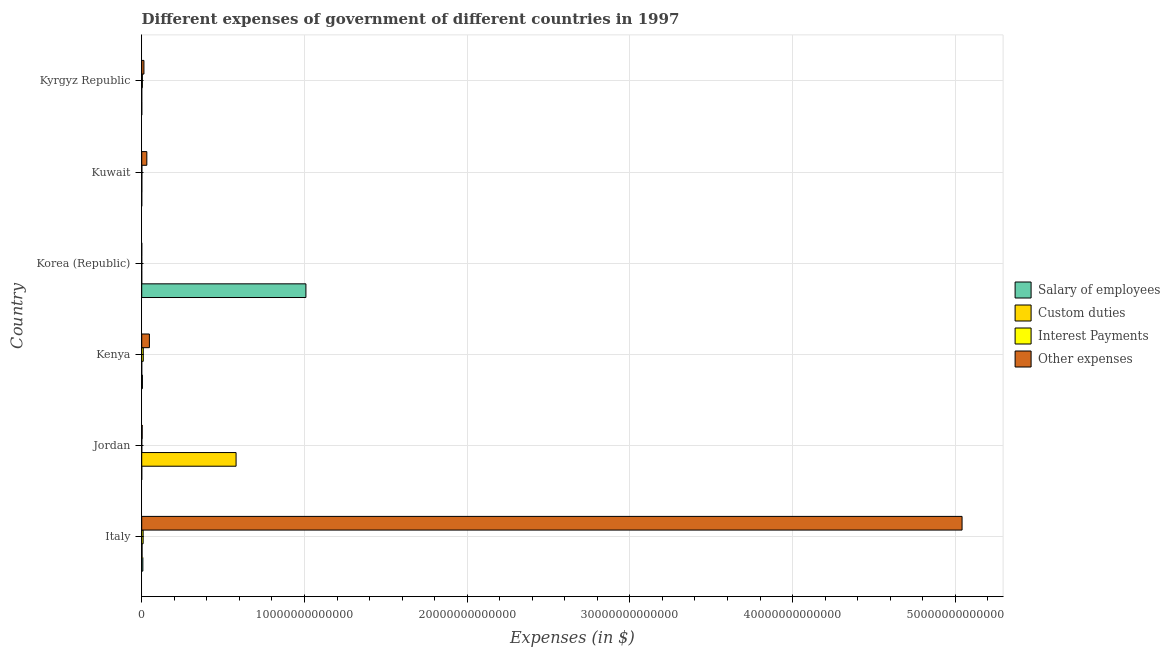Are the number of bars per tick equal to the number of legend labels?
Offer a terse response. Yes. Are the number of bars on each tick of the Y-axis equal?
Offer a very short reply. Yes. How many bars are there on the 2nd tick from the top?
Your answer should be very brief. 4. What is the label of the 1st group of bars from the top?
Provide a succinct answer. Kyrgyz Republic. In how many cases, is the number of bars for a given country not equal to the number of legend labels?
Offer a terse response. 0. What is the amount spent on custom duties in Kuwait?
Keep it short and to the point. 6.52e+09. Across all countries, what is the maximum amount spent on interest payments?
Offer a very short reply. 9.54e+1. Across all countries, what is the minimum amount spent on interest payments?
Keep it short and to the point. 2.01e+08. What is the total amount spent on custom duties in the graph?
Offer a very short reply. 5.83e+12. What is the difference between the amount spent on salary of employees in Jordan and that in Kenya?
Provide a succinct answer. -4.16e+1. What is the difference between the amount spent on custom duties in Kyrgyz Republic and the amount spent on interest payments in Italy?
Ensure brevity in your answer.  -8.64e+1. What is the average amount spent on custom duties per country?
Give a very brief answer. 9.71e+11. What is the difference between the amount spent on other expenses and amount spent on interest payments in Korea (Republic)?
Offer a very short reply. 1.26e+09. What is the ratio of the amount spent on other expenses in Italy to that in Kuwait?
Offer a very short reply. 160.86. Is the difference between the amount spent on interest payments in Kenya and Korea (Republic) greater than the difference between the amount spent on custom duties in Kenya and Korea (Republic)?
Your answer should be very brief. Yes. What is the difference between the highest and the second highest amount spent on interest payments?
Your answer should be compact. 8.35e+09. What is the difference between the highest and the lowest amount spent on other expenses?
Provide a succinct answer. 5.04e+13. What does the 2nd bar from the top in Kenya represents?
Ensure brevity in your answer.  Interest Payments. What does the 2nd bar from the bottom in Kuwait represents?
Your answer should be compact. Custom duties. How many bars are there?
Your answer should be compact. 24. What is the difference between two consecutive major ticks on the X-axis?
Provide a short and direct response. 1.00e+13. Are the values on the major ticks of X-axis written in scientific E-notation?
Ensure brevity in your answer.  No. Does the graph contain grids?
Your answer should be compact. Yes. How many legend labels are there?
Give a very brief answer. 4. How are the legend labels stacked?
Offer a very short reply. Vertical. What is the title of the graph?
Keep it short and to the point. Different expenses of government of different countries in 1997. What is the label or title of the X-axis?
Make the answer very short. Expenses (in $). What is the label or title of the Y-axis?
Provide a succinct answer. Country. What is the Expenses (in $) in Salary of employees in Italy?
Your response must be concise. 7.01e+1. What is the Expenses (in $) in Custom duties in Italy?
Provide a succinct answer. 2.12e+1. What is the Expenses (in $) of Interest Payments in Italy?
Give a very brief answer. 8.70e+1. What is the Expenses (in $) in Other expenses in Italy?
Keep it short and to the point. 5.04e+13. What is the Expenses (in $) of Salary of employees in Jordan?
Your answer should be very brief. 9.72e+08. What is the Expenses (in $) of Custom duties in Jordan?
Your answer should be very brief. 5.80e+12. What is the Expenses (in $) in Interest Payments in Jordan?
Your response must be concise. 3.22e+09. What is the Expenses (in $) of Other expenses in Jordan?
Your response must be concise. 2.88e+1. What is the Expenses (in $) of Salary of employees in Kenya?
Ensure brevity in your answer.  4.26e+1. What is the Expenses (in $) in Custom duties in Kenya?
Keep it short and to the point. 8.30e+07. What is the Expenses (in $) of Interest Payments in Kenya?
Provide a short and direct response. 9.54e+1. What is the Expenses (in $) of Other expenses in Kenya?
Provide a short and direct response. 4.72e+11. What is the Expenses (in $) in Salary of employees in Korea (Republic)?
Give a very brief answer. 1.01e+13. What is the Expenses (in $) in Custom duties in Korea (Republic)?
Provide a short and direct response. 2.20e+07. What is the Expenses (in $) in Interest Payments in Korea (Republic)?
Ensure brevity in your answer.  2.01e+08. What is the Expenses (in $) of Other expenses in Korea (Republic)?
Your answer should be compact. 1.46e+09. What is the Expenses (in $) in Salary of employees in Kuwait?
Give a very brief answer. 1.08e+09. What is the Expenses (in $) in Custom duties in Kuwait?
Your response must be concise. 6.52e+09. What is the Expenses (in $) of Interest Payments in Kuwait?
Make the answer very short. 9.30e+09. What is the Expenses (in $) in Other expenses in Kuwait?
Keep it short and to the point. 3.13e+11. What is the Expenses (in $) in Salary of employees in Kyrgyz Republic?
Provide a short and direct response. 2.20e+09. What is the Expenses (in $) in Custom duties in Kyrgyz Republic?
Your answer should be compact. 5.53e+08. What is the Expenses (in $) of Interest Payments in Kyrgyz Republic?
Provide a succinct answer. 4.00e+1. What is the Expenses (in $) of Other expenses in Kyrgyz Republic?
Your answer should be very brief. 1.36e+11. Across all countries, what is the maximum Expenses (in $) of Salary of employees?
Provide a succinct answer. 1.01e+13. Across all countries, what is the maximum Expenses (in $) of Custom duties?
Give a very brief answer. 5.80e+12. Across all countries, what is the maximum Expenses (in $) in Interest Payments?
Offer a very short reply. 9.54e+1. Across all countries, what is the maximum Expenses (in $) of Other expenses?
Provide a short and direct response. 5.04e+13. Across all countries, what is the minimum Expenses (in $) in Salary of employees?
Provide a succinct answer. 9.72e+08. Across all countries, what is the minimum Expenses (in $) in Custom duties?
Your answer should be compact. 2.20e+07. Across all countries, what is the minimum Expenses (in $) of Interest Payments?
Your answer should be very brief. 2.01e+08. Across all countries, what is the minimum Expenses (in $) of Other expenses?
Provide a short and direct response. 1.46e+09. What is the total Expenses (in $) in Salary of employees in the graph?
Offer a terse response. 1.02e+13. What is the total Expenses (in $) in Custom duties in the graph?
Provide a short and direct response. 5.83e+12. What is the total Expenses (in $) of Interest Payments in the graph?
Your answer should be very brief. 2.35e+11. What is the total Expenses (in $) in Other expenses in the graph?
Provide a succinct answer. 5.14e+13. What is the difference between the Expenses (in $) of Salary of employees in Italy and that in Jordan?
Offer a very short reply. 6.91e+1. What is the difference between the Expenses (in $) in Custom duties in Italy and that in Jordan?
Offer a terse response. -5.78e+12. What is the difference between the Expenses (in $) of Interest Payments in Italy and that in Jordan?
Keep it short and to the point. 8.38e+1. What is the difference between the Expenses (in $) of Other expenses in Italy and that in Jordan?
Keep it short and to the point. 5.04e+13. What is the difference between the Expenses (in $) in Salary of employees in Italy and that in Kenya?
Provide a succinct answer. 2.75e+1. What is the difference between the Expenses (in $) in Custom duties in Italy and that in Kenya?
Offer a terse response. 2.11e+1. What is the difference between the Expenses (in $) of Interest Payments in Italy and that in Kenya?
Your response must be concise. -8.35e+09. What is the difference between the Expenses (in $) in Other expenses in Italy and that in Kenya?
Make the answer very short. 4.99e+13. What is the difference between the Expenses (in $) of Salary of employees in Italy and that in Korea (Republic)?
Your answer should be compact. -1.00e+13. What is the difference between the Expenses (in $) of Custom duties in Italy and that in Korea (Republic)?
Provide a short and direct response. 2.12e+1. What is the difference between the Expenses (in $) of Interest Payments in Italy and that in Korea (Republic)?
Offer a very short reply. 8.68e+1. What is the difference between the Expenses (in $) in Other expenses in Italy and that in Korea (Republic)?
Your answer should be compact. 5.04e+13. What is the difference between the Expenses (in $) of Salary of employees in Italy and that in Kuwait?
Give a very brief answer. 6.90e+1. What is the difference between the Expenses (in $) of Custom duties in Italy and that in Kuwait?
Your answer should be very brief. 1.47e+1. What is the difference between the Expenses (in $) in Interest Payments in Italy and that in Kuwait?
Ensure brevity in your answer.  7.77e+1. What is the difference between the Expenses (in $) of Other expenses in Italy and that in Kuwait?
Make the answer very short. 5.01e+13. What is the difference between the Expenses (in $) in Salary of employees in Italy and that in Kyrgyz Republic?
Keep it short and to the point. 6.79e+1. What is the difference between the Expenses (in $) in Custom duties in Italy and that in Kyrgyz Republic?
Make the answer very short. 2.06e+1. What is the difference between the Expenses (in $) of Interest Payments in Italy and that in Kyrgyz Republic?
Keep it short and to the point. 4.70e+1. What is the difference between the Expenses (in $) of Other expenses in Italy and that in Kyrgyz Republic?
Offer a terse response. 5.03e+13. What is the difference between the Expenses (in $) in Salary of employees in Jordan and that in Kenya?
Ensure brevity in your answer.  -4.16e+1. What is the difference between the Expenses (in $) of Custom duties in Jordan and that in Kenya?
Make the answer very short. 5.80e+12. What is the difference between the Expenses (in $) in Interest Payments in Jordan and that in Kenya?
Offer a very short reply. -9.21e+1. What is the difference between the Expenses (in $) of Other expenses in Jordan and that in Kenya?
Offer a very short reply. -4.43e+11. What is the difference between the Expenses (in $) of Salary of employees in Jordan and that in Korea (Republic)?
Offer a very short reply. -1.01e+13. What is the difference between the Expenses (in $) in Custom duties in Jordan and that in Korea (Republic)?
Provide a succinct answer. 5.80e+12. What is the difference between the Expenses (in $) of Interest Payments in Jordan and that in Korea (Republic)?
Offer a very short reply. 3.02e+09. What is the difference between the Expenses (in $) of Other expenses in Jordan and that in Korea (Republic)?
Offer a very short reply. 2.74e+1. What is the difference between the Expenses (in $) in Salary of employees in Jordan and that in Kuwait?
Keep it short and to the point. -1.03e+08. What is the difference between the Expenses (in $) of Custom duties in Jordan and that in Kuwait?
Make the answer very short. 5.79e+12. What is the difference between the Expenses (in $) in Interest Payments in Jordan and that in Kuwait?
Make the answer very short. -6.08e+09. What is the difference between the Expenses (in $) of Other expenses in Jordan and that in Kuwait?
Offer a very short reply. -2.85e+11. What is the difference between the Expenses (in $) in Salary of employees in Jordan and that in Kyrgyz Republic?
Offer a very short reply. -1.22e+09. What is the difference between the Expenses (in $) in Custom duties in Jordan and that in Kyrgyz Republic?
Your answer should be compact. 5.80e+12. What is the difference between the Expenses (in $) in Interest Payments in Jordan and that in Kyrgyz Republic?
Your response must be concise. -3.68e+1. What is the difference between the Expenses (in $) of Other expenses in Jordan and that in Kyrgyz Republic?
Make the answer very short. -1.08e+11. What is the difference between the Expenses (in $) in Salary of employees in Kenya and that in Korea (Republic)?
Provide a short and direct response. -1.00e+13. What is the difference between the Expenses (in $) of Custom duties in Kenya and that in Korea (Republic)?
Offer a terse response. 6.10e+07. What is the difference between the Expenses (in $) of Interest Payments in Kenya and that in Korea (Republic)?
Your answer should be very brief. 9.52e+1. What is the difference between the Expenses (in $) in Other expenses in Kenya and that in Korea (Republic)?
Offer a very short reply. 4.70e+11. What is the difference between the Expenses (in $) in Salary of employees in Kenya and that in Kuwait?
Your response must be concise. 4.15e+1. What is the difference between the Expenses (in $) in Custom duties in Kenya and that in Kuwait?
Your response must be concise. -6.44e+09. What is the difference between the Expenses (in $) in Interest Payments in Kenya and that in Kuwait?
Offer a terse response. 8.61e+1. What is the difference between the Expenses (in $) in Other expenses in Kenya and that in Kuwait?
Provide a short and direct response. 1.58e+11. What is the difference between the Expenses (in $) of Salary of employees in Kenya and that in Kyrgyz Republic?
Your answer should be very brief. 4.04e+1. What is the difference between the Expenses (in $) of Custom duties in Kenya and that in Kyrgyz Republic?
Give a very brief answer. -4.70e+08. What is the difference between the Expenses (in $) of Interest Payments in Kenya and that in Kyrgyz Republic?
Provide a short and direct response. 5.54e+1. What is the difference between the Expenses (in $) in Other expenses in Kenya and that in Kyrgyz Republic?
Your response must be concise. 3.35e+11. What is the difference between the Expenses (in $) in Salary of employees in Korea (Republic) and that in Kuwait?
Your answer should be compact. 1.01e+13. What is the difference between the Expenses (in $) of Custom duties in Korea (Republic) and that in Kuwait?
Give a very brief answer. -6.50e+09. What is the difference between the Expenses (in $) of Interest Payments in Korea (Republic) and that in Kuwait?
Provide a succinct answer. -9.10e+09. What is the difference between the Expenses (in $) of Other expenses in Korea (Republic) and that in Kuwait?
Keep it short and to the point. -3.12e+11. What is the difference between the Expenses (in $) in Salary of employees in Korea (Republic) and that in Kyrgyz Republic?
Offer a terse response. 1.01e+13. What is the difference between the Expenses (in $) in Custom duties in Korea (Republic) and that in Kyrgyz Republic?
Offer a terse response. -5.31e+08. What is the difference between the Expenses (in $) in Interest Payments in Korea (Republic) and that in Kyrgyz Republic?
Your response must be concise. -3.98e+1. What is the difference between the Expenses (in $) of Other expenses in Korea (Republic) and that in Kyrgyz Republic?
Provide a succinct answer. -1.35e+11. What is the difference between the Expenses (in $) in Salary of employees in Kuwait and that in Kyrgyz Republic?
Provide a short and direct response. -1.12e+09. What is the difference between the Expenses (in $) in Custom duties in Kuwait and that in Kyrgyz Republic?
Your response must be concise. 5.97e+09. What is the difference between the Expenses (in $) in Interest Payments in Kuwait and that in Kyrgyz Republic?
Your answer should be compact. -3.07e+1. What is the difference between the Expenses (in $) of Other expenses in Kuwait and that in Kyrgyz Republic?
Give a very brief answer. 1.77e+11. What is the difference between the Expenses (in $) of Salary of employees in Italy and the Expenses (in $) of Custom duties in Jordan?
Offer a terse response. -5.73e+12. What is the difference between the Expenses (in $) of Salary of employees in Italy and the Expenses (in $) of Interest Payments in Jordan?
Offer a very short reply. 6.69e+1. What is the difference between the Expenses (in $) of Salary of employees in Italy and the Expenses (in $) of Other expenses in Jordan?
Give a very brief answer. 4.13e+1. What is the difference between the Expenses (in $) of Custom duties in Italy and the Expenses (in $) of Interest Payments in Jordan?
Ensure brevity in your answer.  1.80e+1. What is the difference between the Expenses (in $) of Custom duties in Italy and the Expenses (in $) of Other expenses in Jordan?
Provide a short and direct response. -7.65e+09. What is the difference between the Expenses (in $) of Interest Payments in Italy and the Expenses (in $) of Other expenses in Jordan?
Your response must be concise. 5.82e+1. What is the difference between the Expenses (in $) of Salary of employees in Italy and the Expenses (in $) of Custom duties in Kenya?
Offer a terse response. 7.00e+1. What is the difference between the Expenses (in $) of Salary of employees in Italy and the Expenses (in $) of Interest Payments in Kenya?
Keep it short and to the point. -2.52e+1. What is the difference between the Expenses (in $) of Salary of employees in Italy and the Expenses (in $) of Other expenses in Kenya?
Your answer should be compact. -4.01e+11. What is the difference between the Expenses (in $) in Custom duties in Italy and the Expenses (in $) in Interest Payments in Kenya?
Make the answer very short. -7.42e+1. What is the difference between the Expenses (in $) of Custom duties in Italy and the Expenses (in $) of Other expenses in Kenya?
Offer a terse response. -4.50e+11. What is the difference between the Expenses (in $) in Interest Payments in Italy and the Expenses (in $) in Other expenses in Kenya?
Your answer should be compact. -3.85e+11. What is the difference between the Expenses (in $) in Salary of employees in Italy and the Expenses (in $) in Custom duties in Korea (Republic)?
Your answer should be compact. 7.01e+1. What is the difference between the Expenses (in $) in Salary of employees in Italy and the Expenses (in $) in Interest Payments in Korea (Republic)?
Provide a short and direct response. 6.99e+1. What is the difference between the Expenses (in $) of Salary of employees in Italy and the Expenses (in $) of Other expenses in Korea (Republic)?
Provide a short and direct response. 6.86e+1. What is the difference between the Expenses (in $) of Custom duties in Italy and the Expenses (in $) of Interest Payments in Korea (Republic)?
Offer a terse response. 2.10e+1. What is the difference between the Expenses (in $) in Custom duties in Italy and the Expenses (in $) in Other expenses in Korea (Republic)?
Ensure brevity in your answer.  1.97e+1. What is the difference between the Expenses (in $) of Interest Payments in Italy and the Expenses (in $) of Other expenses in Korea (Republic)?
Your answer should be very brief. 8.55e+1. What is the difference between the Expenses (in $) of Salary of employees in Italy and the Expenses (in $) of Custom duties in Kuwait?
Your answer should be compact. 6.36e+1. What is the difference between the Expenses (in $) of Salary of employees in Italy and the Expenses (in $) of Interest Payments in Kuwait?
Offer a very short reply. 6.08e+1. What is the difference between the Expenses (in $) of Salary of employees in Italy and the Expenses (in $) of Other expenses in Kuwait?
Make the answer very short. -2.43e+11. What is the difference between the Expenses (in $) in Custom duties in Italy and the Expenses (in $) in Interest Payments in Kuwait?
Offer a terse response. 1.19e+1. What is the difference between the Expenses (in $) in Custom duties in Italy and the Expenses (in $) in Other expenses in Kuwait?
Ensure brevity in your answer.  -2.92e+11. What is the difference between the Expenses (in $) in Interest Payments in Italy and the Expenses (in $) in Other expenses in Kuwait?
Provide a succinct answer. -2.26e+11. What is the difference between the Expenses (in $) in Salary of employees in Italy and the Expenses (in $) in Custom duties in Kyrgyz Republic?
Offer a very short reply. 6.96e+1. What is the difference between the Expenses (in $) of Salary of employees in Italy and the Expenses (in $) of Interest Payments in Kyrgyz Republic?
Ensure brevity in your answer.  3.01e+1. What is the difference between the Expenses (in $) in Salary of employees in Italy and the Expenses (in $) in Other expenses in Kyrgyz Republic?
Provide a short and direct response. -6.64e+1. What is the difference between the Expenses (in $) in Custom duties in Italy and the Expenses (in $) in Interest Payments in Kyrgyz Republic?
Provide a succinct answer. -1.88e+1. What is the difference between the Expenses (in $) in Custom duties in Italy and the Expenses (in $) in Other expenses in Kyrgyz Republic?
Keep it short and to the point. -1.15e+11. What is the difference between the Expenses (in $) in Interest Payments in Italy and the Expenses (in $) in Other expenses in Kyrgyz Republic?
Provide a short and direct response. -4.95e+1. What is the difference between the Expenses (in $) in Salary of employees in Jordan and the Expenses (in $) in Custom duties in Kenya?
Provide a short and direct response. 8.89e+08. What is the difference between the Expenses (in $) of Salary of employees in Jordan and the Expenses (in $) of Interest Payments in Kenya?
Offer a terse response. -9.44e+1. What is the difference between the Expenses (in $) of Salary of employees in Jordan and the Expenses (in $) of Other expenses in Kenya?
Offer a terse response. -4.71e+11. What is the difference between the Expenses (in $) in Custom duties in Jordan and the Expenses (in $) in Interest Payments in Kenya?
Provide a short and direct response. 5.70e+12. What is the difference between the Expenses (in $) of Custom duties in Jordan and the Expenses (in $) of Other expenses in Kenya?
Provide a succinct answer. 5.33e+12. What is the difference between the Expenses (in $) of Interest Payments in Jordan and the Expenses (in $) of Other expenses in Kenya?
Provide a succinct answer. -4.68e+11. What is the difference between the Expenses (in $) in Salary of employees in Jordan and the Expenses (in $) in Custom duties in Korea (Republic)?
Provide a succinct answer. 9.50e+08. What is the difference between the Expenses (in $) in Salary of employees in Jordan and the Expenses (in $) in Interest Payments in Korea (Republic)?
Provide a succinct answer. 7.72e+08. What is the difference between the Expenses (in $) in Salary of employees in Jordan and the Expenses (in $) in Other expenses in Korea (Republic)?
Keep it short and to the point. -4.88e+08. What is the difference between the Expenses (in $) of Custom duties in Jordan and the Expenses (in $) of Interest Payments in Korea (Republic)?
Your answer should be compact. 5.80e+12. What is the difference between the Expenses (in $) of Custom duties in Jordan and the Expenses (in $) of Other expenses in Korea (Republic)?
Ensure brevity in your answer.  5.80e+12. What is the difference between the Expenses (in $) of Interest Payments in Jordan and the Expenses (in $) of Other expenses in Korea (Republic)?
Offer a very short reply. 1.76e+09. What is the difference between the Expenses (in $) of Salary of employees in Jordan and the Expenses (in $) of Custom duties in Kuwait?
Keep it short and to the point. -5.55e+09. What is the difference between the Expenses (in $) in Salary of employees in Jordan and the Expenses (in $) in Interest Payments in Kuwait?
Keep it short and to the point. -8.33e+09. What is the difference between the Expenses (in $) of Salary of employees in Jordan and the Expenses (in $) of Other expenses in Kuwait?
Your response must be concise. -3.12e+11. What is the difference between the Expenses (in $) in Custom duties in Jordan and the Expenses (in $) in Interest Payments in Kuwait?
Your answer should be very brief. 5.79e+12. What is the difference between the Expenses (in $) of Custom duties in Jordan and the Expenses (in $) of Other expenses in Kuwait?
Provide a succinct answer. 5.48e+12. What is the difference between the Expenses (in $) of Interest Payments in Jordan and the Expenses (in $) of Other expenses in Kuwait?
Provide a short and direct response. -3.10e+11. What is the difference between the Expenses (in $) in Salary of employees in Jordan and the Expenses (in $) in Custom duties in Kyrgyz Republic?
Provide a succinct answer. 4.20e+08. What is the difference between the Expenses (in $) in Salary of employees in Jordan and the Expenses (in $) in Interest Payments in Kyrgyz Republic?
Give a very brief answer. -3.90e+1. What is the difference between the Expenses (in $) in Salary of employees in Jordan and the Expenses (in $) in Other expenses in Kyrgyz Republic?
Your answer should be compact. -1.35e+11. What is the difference between the Expenses (in $) of Custom duties in Jordan and the Expenses (in $) of Interest Payments in Kyrgyz Republic?
Ensure brevity in your answer.  5.76e+12. What is the difference between the Expenses (in $) of Custom duties in Jordan and the Expenses (in $) of Other expenses in Kyrgyz Republic?
Your response must be concise. 5.66e+12. What is the difference between the Expenses (in $) of Interest Payments in Jordan and the Expenses (in $) of Other expenses in Kyrgyz Republic?
Keep it short and to the point. -1.33e+11. What is the difference between the Expenses (in $) of Salary of employees in Kenya and the Expenses (in $) of Custom duties in Korea (Republic)?
Provide a short and direct response. 4.25e+1. What is the difference between the Expenses (in $) in Salary of employees in Kenya and the Expenses (in $) in Interest Payments in Korea (Republic)?
Make the answer very short. 4.24e+1. What is the difference between the Expenses (in $) in Salary of employees in Kenya and the Expenses (in $) in Other expenses in Korea (Republic)?
Your response must be concise. 4.11e+1. What is the difference between the Expenses (in $) in Custom duties in Kenya and the Expenses (in $) in Interest Payments in Korea (Republic)?
Ensure brevity in your answer.  -1.18e+08. What is the difference between the Expenses (in $) in Custom duties in Kenya and the Expenses (in $) in Other expenses in Korea (Republic)?
Ensure brevity in your answer.  -1.38e+09. What is the difference between the Expenses (in $) of Interest Payments in Kenya and the Expenses (in $) of Other expenses in Korea (Republic)?
Keep it short and to the point. 9.39e+1. What is the difference between the Expenses (in $) of Salary of employees in Kenya and the Expenses (in $) of Custom duties in Kuwait?
Offer a terse response. 3.60e+1. What is the difference between the Expenses (in $) of Salary of employees in Kenya and the Expenses (in $) of Interest Payments in Kuwait?
Make the answer very short. 3.33e+1. What is the difference between the Expenses (in $) of Salary of employees in Kenya and the Expenses (in $) of Other expenses in Kuwait?
Offer a very short reply. -2.71e+11. What is the difference between the Expenses (in $) in Custom duties in Kenya and the Expenses (in $) in Interest Payments in Kuwait?
Your response must be concise. -9.22e+09. What is the difference between the Expenses (in $) of Custom duties in Kenya and the Expenses (in $) of Other expenses in Kuwait?
Keep it short and to the point. -3.13e+11. What is the difference between the Expenses (in $) in Interest Payments in Kenya and the Expenses (in $) in Other expenses in Kuwait?
Your answer should be very brief. -2.18e+11. What is the difference between the Expenses (in $) of Salary of employees in Kenya and the Expenses (in $) of Custom duties in Kyrgyz Republic?
Give a very brief answer. 4.20e+1. What is the difference between the Expenses (in $) of Salary of employees in Kenya and the Expenses (in $) of Interest Payments in Kyrgyz Republic?
Make the answer very short. 2.58e+09. What is the difference between the Expenses (in $) in Salary of employees in Kenya and the Expenses (in $) in Other expenses in Kyrgyz Republic?
Provide a short and direct response. -9.39e+1. What is the difference between the Expenses (in $) in Custom duties in Kenya and the Expenses (in $) in Interest Payments in Kyrgyz Republic?
Make the answer very short. -3.99e+1. What is the difference between the Expenses (in $) in Custom duties in Kenya and the Expenses (in $) in Other expenses in Kyrgyz Republic?
Offer a terse response. -1.36e+11. What is the difference between the Expenses (in $) of Interest Payments in Kenya and the Expenses (in $) of Other expenses in Kyrgyz Republic?
Your response must be concise. -4.11e+1. What is the difference between the Expenses (in $) of Salary of employees in Korea (Republic) and the Expenses (in $) of Custom duties in Kuwait?
Your answer should be very brief. 1.01e+13. What is the difference between the Expenses (in $) of Salary of employees in Korea (Republic) and the Expenses (in $) of Interest Payments in Kuwait?
Provide a succinct answer. 1.01e+13. What is the difference between the Expenses (in $) in Salary of employees in Korea (Republic) and the Expenses (in $) in Other expenses in Kuwait?
Offer a very short reply. 9.78e+12. What is the difference between the Expenses (in $) of Custom duties in Korea (Republic) and the Expenses (in $) of Interest Payments in Kuwait?
Your answer should be very brief. -9.28e+09. What is the difference between the Expenses (in $) in Custom duties in Korea (Republic) and the Expenses (in $) in Other expenses in Kuwait?
Your answer should be very brief. -3.13e+11. What is the difference between the Expenses (in $) in Interest Payments in Korea (Republic) and the Expenses (in $) in Other expenses in Kuwait?
Ensure brevity in your answer.  -3.13e+11. What is the difference between the Expenses (in $) of Salary of employees in Korea (Republic) and the Expenses (in $) of Custom duties in Kyrgyz Republic?
Your answer should be very brief. 1.01e+13. What is the difference between the Expenses (in $) in Salary of employees in Korea (Republic) and the Expenses (in $) in Interest Payments in Kyrgyz Republic?
Keep it short and to the point. 1.01e+13. What is the difference between the Expenses (in $) in Salary of employees in Korea (Republic) and the Expenses (in $) in Other expenses in Kyrgyz Republic?
Make the answer very short. 9.95e+12. What is the difference between the Expenses (in $) in Custom duties in Korea (Republic) and the Expenses (in $) in Interest Payments in Kyrgyz Republic?
Provide a short and direct response. -4.00e+1. What is the difference between the Expenses (in $) in Custom duties in Korea (Republic) and the Expenses (in $) in Other expenses in Kyrgyz Republic?
Ensure brevity in your answer.  -1.36e+11. What is the difference between the Expenses (in $) of Interest Payments in Korea (Republic) and the Expenses (in $) of Other expenses in Kyrgyz Republic?
Offer a terse response. -1.36e+11. What is the difference between the Expenses (in $) in Salary of employees in Kuwait and the Expenses (in $) in Custom duties in Kyrgyz Republic?
Your answer should be compact. 5.22e+08. What is the difference between the Expenses (in $) in Salary of employees in Kuwait and the Expenses (in $) in Interest Payments in Kyrgyz Republic?
Make the answer very short. -3.89e+1. What is the difference between the Expenses (in $) of Salary of employees in Kuwait and the Expenses (in $) of Other expenses in Kyrgyz Republic?
Provide a succinct answer. -1.35e+11. What is the difference between the Expenses (in $) of Custom duties in Kuwait and the Expenses (in $) of Interest Payments in Kyrgyz Republic?
Provide a short and direct response. -3.35e+1. What is the difference between the Expenses (in $) in Custom duties in Kuwait and the Expenses (in $) in Other expenses in Kyrgyz Republic?
Make the answer very short. -1.30e+11. What is the difference between the Expenses (in $) in Interest Payments in Kuwait and the Expenses (in $) in Other expenses in Kyrgyz Republic?
Offer a very short reply. -1.27e+11. What is the average Expenses (in $) in Salary of employees per country?
Give a very brief answer. 1.70e+12. What is the average Expenses (in $) of Custom duties per country?
Provide a succinct answer. 9.71e+11. What is the average Expenses (in $) of Interest Payments per country?
Your response must be concise. 3.92e+1. What is the average Expenses (in $) of Other expenses per country?
Provide a short and direct response. 8.56e+12. What is the difference between the Expenses (in $) of Salary of employees and Expenses (in $) of Custom duties in Italy?
Offer a terse response. 4.89e+1. What is the difference between the Expenses (in $) in Salary of employees and Expenses (in $) in Interest Payments in Italy?
Ensure brevity in your answer.  -1.69e+1. What is the difference between the Expenses (in $) of Salary of employees and Expenses (in $) of Other expenses in Italy?
Your answer should be compact. -5.03e+13. What is the difference between the Expenses (in $) of Custom duties and Expenses (in $) of Interest Payments in Italy?
Keep it short and to the point. -6.58e+1. What is the difference between the Expenses (in $) of Custom duties and Expenses (in $) of Other expenses in Italy?
Ensure brevity in your answer.  -5.04e+13. What is the difference between the Expenses (in $) in Interest Payments and Expenses (in $) in Other expenses in Italy?
Keep it short and to the point. -5.03e+13. What is the difference between the Expenses (in $) in Salary of employees and Expenses (in $) in Custom duties in Jordan?
Make the answer very short. -5.80e+12. What is the difference between the Expenses (in $) of Salary of employees and Expenses (in $) of Interest Payments in Jordan?
Keep it short and to the point. -2.24e+09. What is the difference between the Expenses (in $) of Salary of employees and Expenses (in $) of Other expenses in Jordan?
Provide a succinct answer. -2.79e+1. What is the difference between the Expenses (in $) in Custom duties and Expenses (in $) in Interest Payments in Jordan?
Your answer should be compact. 5.79e+12. What is the difference between the Expenses (in $) of Custom duties and Expenses (in $) of Other expenses in Jordan?
Offer a very short reply. 5.77e+12. What is the difference between the Expenses (in $) in Interest Payments and Expenses (in $) in Other expenses in Jordan?
Your answer should be very brief. -2.56e+1. What is the difference between the Expenses (in $) in Salary of employees and Expenses (in $) in Custom duties in Kenya?
Offer a terse response. 4.25e+1. What is the difference between the Expenses (in $) of Salary of employees and Expenses (in $) of Interest Payments in Kenya?
Provide a short and direct response. -5.28e+1. What is the difference between the Expenses (in $) of Salary of employees and Expenses (in $) of Other expenses in Kenya?
Offer a very short reply. -4.29e+11. What is the difference between the Expenses (in $) in Custom duties and Expenses (in $) in Interest Payments in Kenya?
Ensure brevity in your answer.  -9.53e+1. What is the difference between the Expenses (in $) in Custom duties and Expenses (in $) in Other expenses in Kenya?
Give a very brief answer. -4.71e+11. What is the difference between the Expenses (in $) in Interest Payments and Expenses (in $) in Other expenses in Kenya?
Your answer should be very brief. -3.76e+11. What is the difference between the Expenses (in $) of Salary of employees and Expenses (in $) of Custom duties in Korea (Republic)?
Your answer should be compact. 1.01e+13. What is the difference between the Expenses (in $) of Salary of employees and Expenses (in $) of Interest Payments in Korea (Republic)?
Your response must be concise. 1.01e+13. What is the difference between the Expenses (in $) of Salary of employees and Expenses (in $) of Other expenses in Korea (Republic)?
Offer a very short reply. 1.01e+13. What is the difference between the Expenses (in $) in Custom duties and Expenses (in $) in Interest Payments in Korea (Republic)?
Provide a short and direct response. -1.79e+08. What is the difference between the Expenses (in $) in Custom duties and Expenses (in $) in Other expenses in Korea (Republic)?
Offer a very short reply. -1.44e+09. What is the difference between the Expenses (in $) in Interest Payments and Expenses (in $) in Other expenses in Korea (Republic)?
Provide a succinct answer. -1.26e+09. What is the difference between the Expenses (in $) in Salary of employees and Expenses (in $) in Custom duties in Kuwait?
Ensure brevity in your answer.  -5.45e+09. What is the difference between the Expenses (in $) of Salary of employees and Expenses (in $) of Interest Payments in Kuwait?
Provide a succinct answer. -8.22e+09. What is the difference between the Expenses (in $) in Salary of employees and Expenses (in $) in Other expenses in Kuwait?
Offer a terse response. -3.12e+11. What is the difference between the Expenses (in $) of Custom duties and Expenses (in $) of Interest Payments in Kuwait?
Your answer should be very brief. -2.78e+09. What is the difference between the Expenses (in $) in Custom duties and Expenses (in $) in Other expenses in Kuwait?
Offer a very short reply. -3.07e+11. What is the difference between the Expenses (in $) in Interest Payments and Expenses (in $) in Other expenses in Kuwait?
Provide a succinct answer. -3.04e+11. What is the difference between the Expenses (in $) of Salary of employees and Expenses (in $) of Custom duties in Kyrgyz Republic?
Your answer should be very brief. 1.64e+09. What is the difference between the Expenses (in $) of Salary of employees and Expenses (in $) of Interest Payments in Kyrgyz Republic?
Provide a short and direct response. -3.78e+1. What is the difference between the Expenses (in $) of Salary of employees and Expenses (in $) of Other expenses in Kyrgyz Republic?
Provide a succinct answer. -1.34e+11. What is the difference between the Expenses (in $) in Custom duties and Expenses (in $) in Interest Payments in Kyrgyz Republic?
Offer a very short reply. -3.94e+1. What is the difference between the Expenses (in $) of Custom duties and Expenses (in $) of Other expenses in Kyrgyz Republic?
Offer a terse response. -1.36e+11. What is the difference between the Expenses (in $) in Interest Payments and Expenses (in $) in Other expenses in Kyrgyz Republic?
Offer a terse response. -9.65e+1. What is the ratio of the Expenses (in $) of Salary of employees in Italy to that in Jordan?
Make the answer very short. 72.09. What is the ratio of the Expenses (in $) in Custom duties in Italy to that in Jordan?
Offer a terse response. 0. What is the ratio of the Expenses (in $) of Interest Payments in Italy to that in Jordan?
Your answer should be compact. 27.04. What is the ratio of the Expenses (in $) in Other expenses in Italy to that in Jordan?
Provide a short and direct response. 1748.76. What is the ratio of the Expenses (in $) in Salary of employees in Italy to that in Kenya?
Provide a succinct answer. 1.65. What is the ratio of the Expenses (in $) of Custom duties in Italy to that in Kenya?
Give a very brief answer. 255.13. What is the ratio of the Expenses (in $) in Interest Payments in Italy to that in Kenya?
Your answer should be very brief. 0.91. What is the ratio of the Expenses (in $) of Other expenses in Italy to that in Kenya?
Your answer should be compact. 106.9. What is the ratio of the Expenses (in $) in Salary of employees in Italy to that in Korea (Republic)?
Offer a very short reply. 0.01. What is the ratio of the Expenses (in $) of Custom duties in Italy to that in Korea (Republic)?
Offer a terse response. 962.55. What is the ratio of the Expenses (in $) in Interest Payments in Italy to that in Korea (Republic)?
Your response must be concise. 433.14. What is the ratio of the Expenses (in $) of Other expenses in Italy to that in Korea (Republic)?
Ensure brevity in your answer.  3.45e+04. What is the ratio of the Expenses (in $) of Salary of employees in Italy to that in Kuwait?
Your answer should be very brief. 65.21. What is the ratio of the Expenses (in $) of Custom duties in Italy to that in Kuwait?
Ensure brevity in your answer.  3.25. What is the ratio of the Expenses (in $) in Interest Payments in Italy to that in Kuwait?
Your answer should be compact. 9.36. What is the ratio of the Expenses (in $) in Other expenses in Italy to that in Kuwait?
Offer a very short reply. 160.86. What is the ratio of the Expenses (in $) in Salary of employees in Italy to that in Kyrgyz Republic?
Make the answer very short. 31.91. What is the ratio of the Expenses (in $) of Custom duties in Italy to that in Kyrgyz Republic?
Give a very brief answer. 38.31. What is the ratio of the Expenses (in $) in Interest Payments in Italy to that in Kyrgyz Republic?
Offer a terse response. 2.18. What is the ratio of the Expenses (in $) of Other expenses in Italy to that in Kyrgyz Republic?
Give a very brief answer. 369.41. What is the ratio of the Expenses (in $) of Salary of employees in Jordan to that in Kenya?
Make the answer very short. 0.02. What is the ratio of the Expenses (in $) in Custom duties in Jordan to that in Kenya?
Offer a very short reply. 6.99e+04. What is the ratio of the Expenses (in $) of Interest Payments in Jordan to that in Kenya?
Your answer should be compact. 0.03. What is the ratio of the Expenses (in $) of Other expenses in Jordan to that in Kenya?
Your response must be concise. 0.06. What is the ratio of the Expenses (in $) of Custom duties in Jordan to that in Korea (Republic)?
Give a very brief answer. 2.64e+05. What is the ratio of the Expenses (in $) in Interest Payments in Jordan to that in Korea (Republic)?
Your answer should be very brief. 16.02. What is the ratio of the Expenses (in $) in Other expenses in Jordan to that in Korea (Republic)?
Offer a terse response. 19.74. What is the ratio of the Expenses (in $) of Salary of employees in Jordan to that in Kuwait?
Ensure brevity in your answer.  0.9. What is the ratio of the Expenses (in $) in Custom duties in Jordan to that in Kuwait?
Make the answer very short. 888.72. What is the ratio of the Expenses (in $) of Interest Payments in Jordan to that in Kuwait?
Provide a short and direct response. 0.35. What is the ratio of the Expenses (in $) in Other expenses in Jordan to that in Kuwait?
Your answer should be compact. 0.09. What is the ratio of the Expenses (in $) in Salary of employees in Jordan to that in Kyrgyz Republic?
Offer a very short reply. 0.44. What is the ratio of the Expenses (in $) in Custom duties in Jordan to that in Kyrgyz Republic?
Give a very brief answer. 1.05e+04. What is the ratio of the Expenses (in $) in Interest Payments in Jordan to that in Kyrgyz Republic?
Offer a terse response. 0.08. What is the ratio of the Expenses (in $) in Other expenses in Jordan to that in Kyrgyz Republic?
Offer a very short reply. 0.21. What is the ratio of the Expenses (in $) of Salary of employees in Kenya to that in Korea (Republic)?
Make the answer very short. 0. What is the ratio of the Expenses (in $) in Custom duties in Kenya to that in Korea (Republic)?
Keep it short and to the point. 3.77. What is the ratio of the Expenses (in $) of Interest Payments in Kenya to that in Korea (Republic)?
Offer a terse response. 474.72. What is the ratio of the Expenses (in $) of Other expenses in Kenya to that in Korea (Republic)?
Give a very brief answer. 323. What is the ratio of the Expenses (in $) of Salary of employees in Kenya to that in Kuwait?
Keep it short and to the point. 39.6. What is the ratio of the Expenses (in $) in Custom duties in Kenya to that in Kuwait?
Keep it short and to the point. 0.01. What is the ratio of the Expenses (in $) in Interest Payments in Kenya to that in Kuwait?
Your answer should be compact. 10.25. What is the ratio of the Expenses (in $) of Other expenses in Kenya to that in Kuwait?
Provide a succinct answer. 1.5. What is the ratio of the Expenses (in $) in Salary of employees in Kenya to that in Kyrgyz Republic?
Your response must be concise. 19.38. What is the ratio of the Expenses (in $) in Custom duties in Kenya to that in Kyrgyz Republic?
Your response must be concise. 0.15. What is the ratio of the Expenses (in $) of Interest Payments in Kenya to that in Kyrgyz Republic?
Your answer should be compact. 2.38. What is the ratio of the Expenses (in $) of Other expenses in Kenya to that in Kyrgyz Republic?
Provide a short and direct response. 3.46. What is the ratio of the Expenses (in $) of Salary of employees in Korea (Republic) to that in Kuwait?
Your answer should be very brief. 9386.98. What is the ratio of the Expenses (in $) of Custom duties in Korea (Republic) to that in Kuwait?
Keep it short and to the point. 0. What is the ratio of the Expenses (in $) of Interest Payments in Korea (Republic) to that in Kuwait?
Your response must be concise. 0.02. What is the ratio of the Expenses (in $) of Other expenses in Korea (Republic) to that in Kuwait?
Your response must be concise. 0. What is the ratio of the Expenses (in $) in Salary of employees in Korea (Republic) to that in Kyrgyz Republic?
Your response must be concise. 4593.92. What is the ratio of the Expenses (in $) in Custom duties in Korea (Republic) to that in Kyrgyz Republic?
Your answer should be very brief. 0.04. What is the ratio of the Expenses (in $) in Interest Payments in Korea (Republic) to that in Kyrgyz Republic?
Keep it short and to the point. 0.01. What is the ratio of the Expenses (in $) in Other expenses in Korea (Republic) to that in Kyrgyz Republic?
Your answer should be very brief. 0.01. What is the ratio of the Expenses (in $) in Salary of employees in Kuwait to that in Kyrgyz Republic?
Keep it short and to the point. 0.49. What is the ratio of the Expenses (in $) in Custom duties in Kuwait to that in Kyrgyz Republic?
Provide a short and direct response. 11.8. What is the ratio of the Expenses (in $) in Interest Payments in Kuwait to that in Kyrgyz Republic?
Keep it short and to the point. 0.23. What is the ratio of the Expenses (in $) of Other expenses in Kuwait to that in Kyrgyz Republic?
Make the answer very short. 2.3. What is the difference between the highest and the second highest Expenses (in $) of Salary of employees?
Offer a terse response. 1.00e+13. What is the difference between the highest and the second highest Expenses (in $) of Custom duties?
Make the answer very short. 5.78e+12. What is the difference between the highest and the second highest Expenses (in $) of Interest Payments?
Provide a succinct answer. 8.35e+09. What is the difference between the highest and the second highest Expenses (in $) in Other expenses?
Provide a short and direct response. 4.99e+13. What is the difference between the highest and the lowest Expenses (in $) in Salary of employees?
Your answer should be very brief. 1.01e+13. What is the difference between the highest and the lowest Expenses (in $) of Custom duties?
Ensure brevity in your answer.  5.80e+12. What is the difference between the highest and the lowest Expenses (in $) of Interest Payments?
Provide a succinct answer. 9.52e+1. What is the difference between the highest and the lowest Expenses (in $) of Other expenses?
Your answer should be compact. 5.04e+13. 